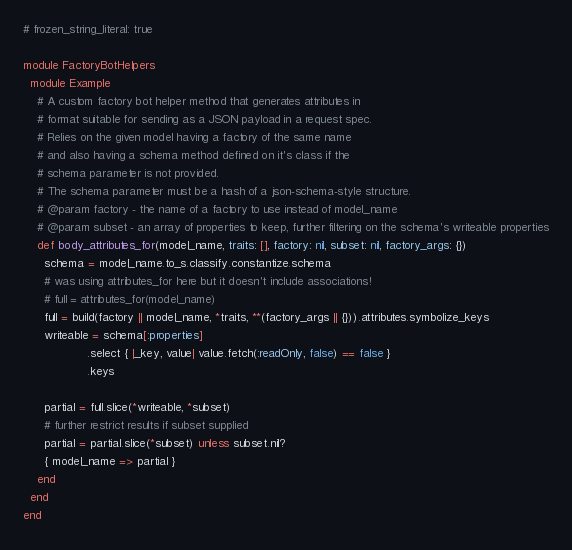Convert code to text. <code><loc_0><loc_0><loc_500><loc_500><_Ruby_># frozen_string_literal: true

module FactoryBotHelpers
  module Example
    # A custom factory bot helper method that generates attributes in
    # format suitable for sending as a JSON payload in a request spec.
    # Relies on the given model having a factory of the same name
    # and also having a schema method defined on it's class if the
    # schema parameter is not provided.
    # The schema parameter must be a hash of a json-schema-style structure.
    # @param factory - the name of a factory to use instead of model_name
    # @param subset - an array of properties to keep, further filtering on the schema's writeable properties
    def body_attributes_for(model_name, traits: [], factory: nil, subset: nil, factory_args: {})
      schema = model_name.to_s.classify.constantize.schema
      # was using attributes_for here but it doesn't include associations!
      # full = attributes_for(model_name)
      full = build(factory || model_name, *traits, **(factory_args || {})).attributes.symbolize_keys
      writeable = schema[:properties]
                  .select { |_key, value| value.fetch(:readOnly, false) == false }
                  .keys

      partial = full.slice(*writeable, *subset)
      # further restrict results if subset supplied
      partial = partial.slice(*subset) unless subset.nil?
      { model_name => partial }
    end
  end
end
</code> 